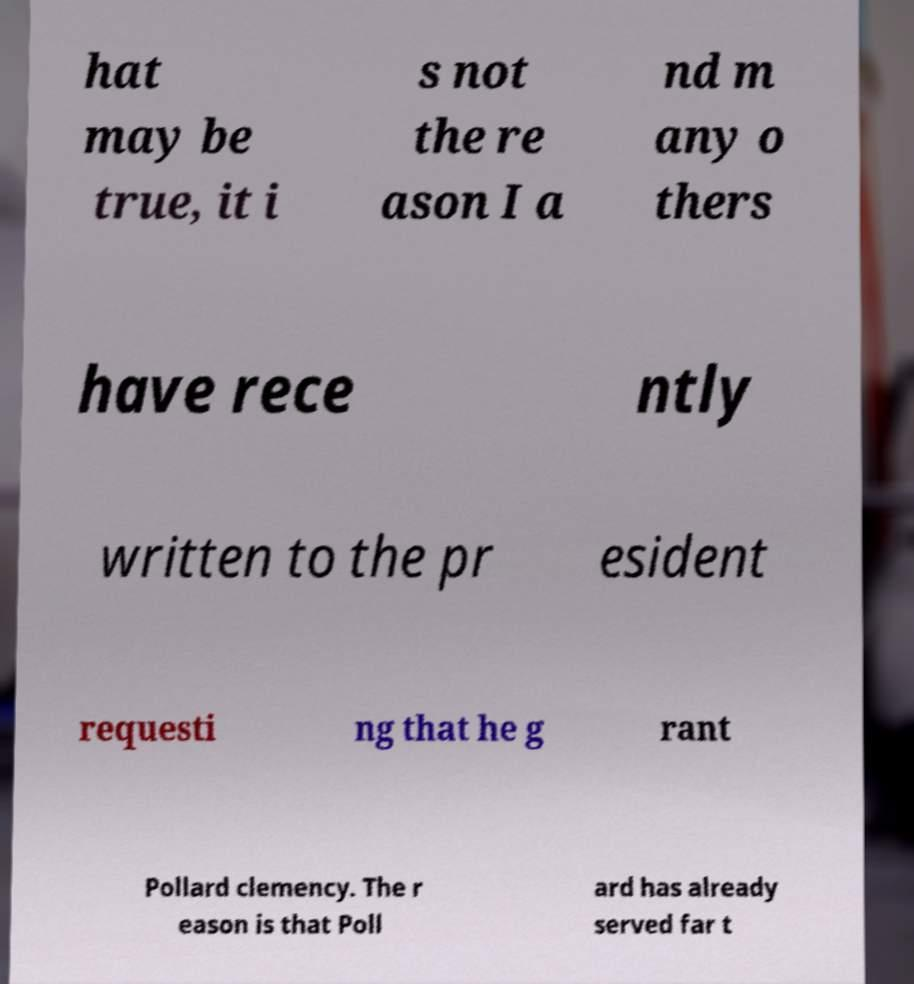Please identify and transcribe the text found in this image. hat may be true, it i s not the re ason I a nd m any o thers have rece ntly written to the pr esident requesti ng that he g rant Pollard clemency. The r eason is that Poll ard has already served far t 